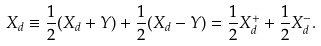Convert formula to latex. <formula><loc_0><loc_0><loc_500><loc_500>X _ { d } \equiv \frac { 1 } { 2 } ( X _ { d } + Y ) + \frac { 1 } { 2 } ( X _ { d } - Y ) = \frac { 1 } { 2 } X _ { d } ^ { + } + \frac { 1 } { 2 } X _ { d } ^ { - } .</formula> 